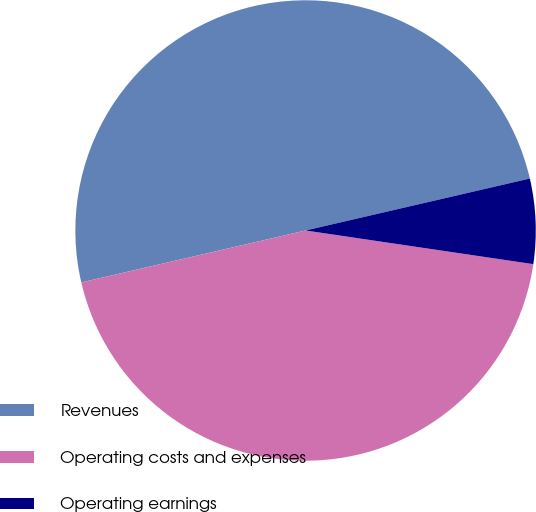<chart> <loc_0><loc_0><loc_500><loc_500><pie_chart><fcel>Revenues<fcel>Operating costs and expenses<fcel>Operating earnings<nl><fcel>50.0%<fcel>44.04%<fcel>5.96%<nl></chart> 